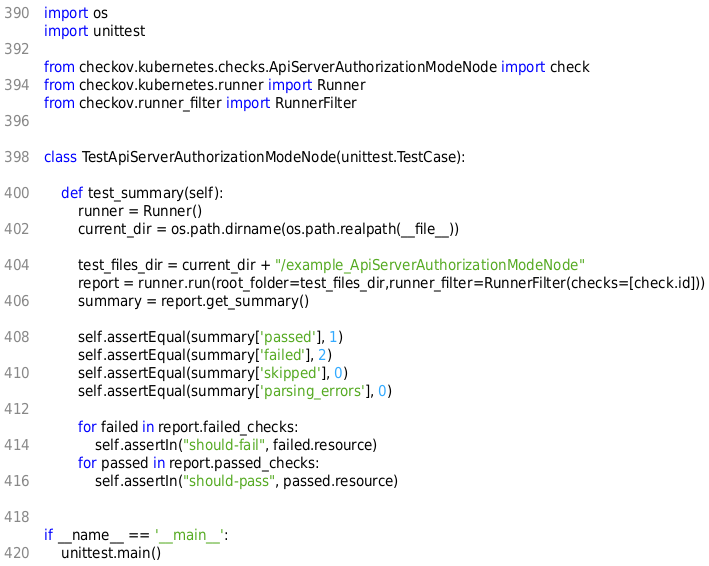<code> <loc_0><loc_0><loc_500><loc_500><_Python_>import os
import unittest

from checkov.kubernetes.checks.ApiServerAuthorizationModeNode import check
from checkov.kubernetes.runner import Runner
from checkov.runner_filter import RunnerFilter


class TestApiServerAuthorizationModeNode(unittest.TestCase):

    def test_summary(self):
        runner = Runner()
        current_dir = os.path.dirname(os.path.realpath(__file__))

        test_files_dir = current_dir + "/example_ApiServerAuthorizationModeNode"
        report = runner.run(root_folder=test_files_dir,runner_filter=RunnerFilter(checks=[check.id]))
        summary = report.get_summary()

        self.assertEqual(summary['passed'], 1)
        self.assertEqual(summary['failed'], 2)
        self.assertEqual(summary['skipped'], 0)
        self.assertEqual(summary['parsing_errors'], 0)

        for failed in report.failed_checks:
            self.assertIn("should-fail", failed.resource)
        for passed in report.passed_checks:
            self.assertIn("should-pass", passed.resource)


if __name__ == '__main__':
    unittest.main()
</code> 